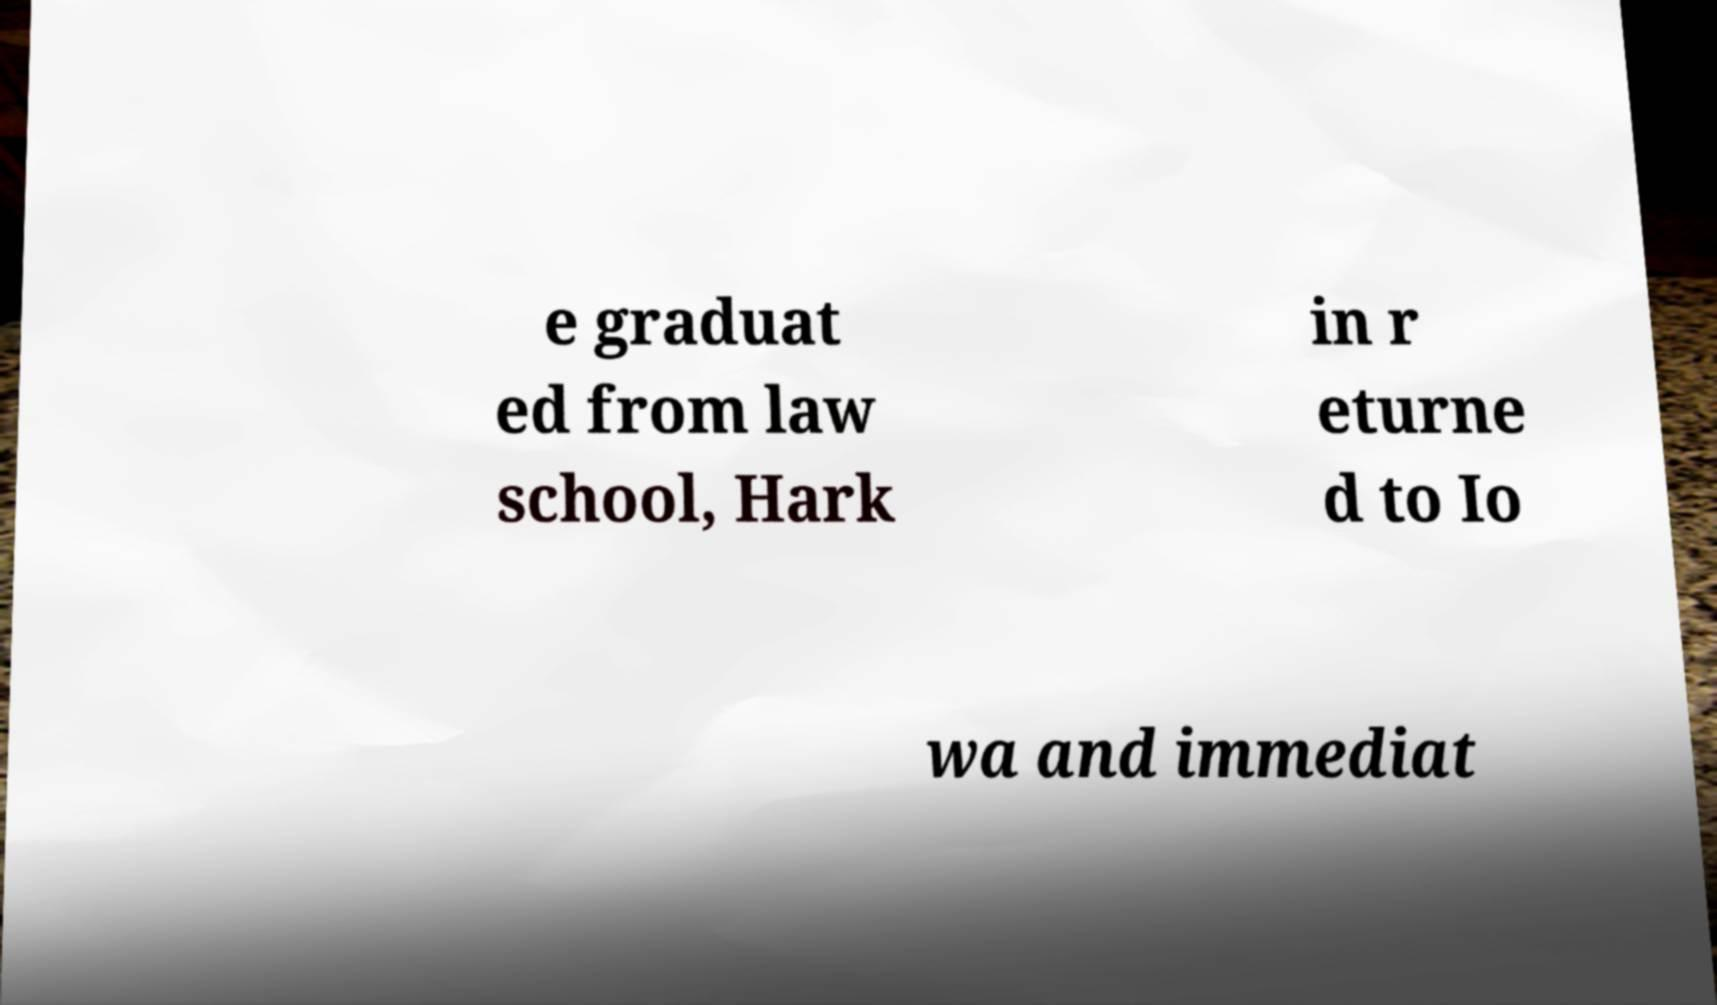Could you assist in decoding the text presented in this image and type it out clearly? e graduat ed from law school, Hark in r eturne d to Io wa and immediat 